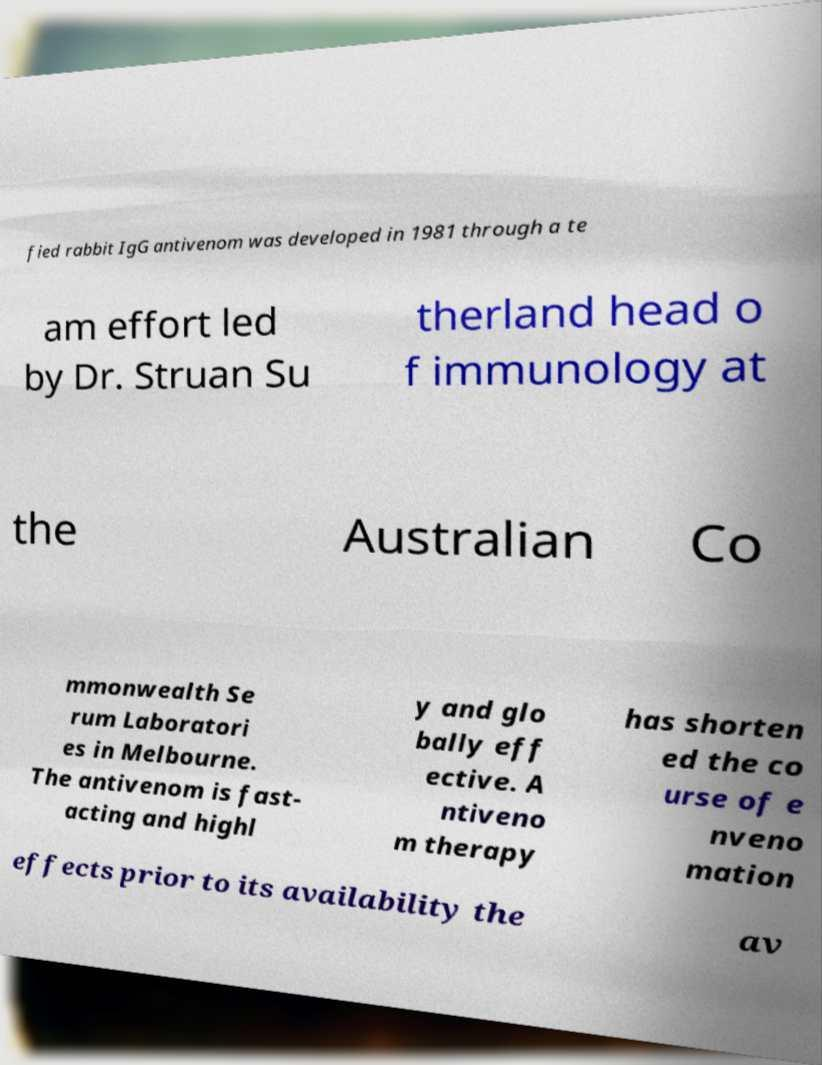Could you assist in decoding the text presented in this image and type it out clearly? fied rabbit IgG antivenom was developed in 1981 through a te am effort led by Dr. Struan Su therland head o f immunology at the Australian Co mmonwealth Se rum Laboratori es in Melbourne. The antivenom is fast- acting and highl y and glo bally eff ective. A ntiveno m therapy has shorten ed the co urse of e nveno mation effects prior to its availability the av 